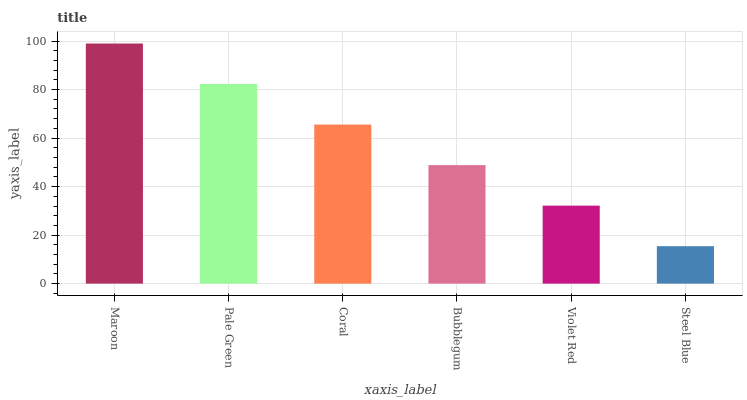Is Steel Blue the minimum?
Answer yes or no. Yes. Is Maroon the maximum?
Answer yes or no. Yes. Is Pale Green the minimum?
Answer yes or no. No. Is Pale Green the maximum?
Answer yes or no. No. Is Maroon greater than Pale Green?
Answer yes or no. Yes. Is Pale Green less than Maroon?
Answer yes or no. Yes. Is Pale Green greater than Maroon?
Answer yes or no. No. Is Maroon less than Pale Green?
Answer yes or no. No. Is Coral the high median?
Answer yes or no. Yes. Is Bubblegum the low median?
Answer yes or no. Yes. Is Pale Green the high median?
Answer yes or no. No. Is Pale Green the low median?
Answer yes or no. No. 